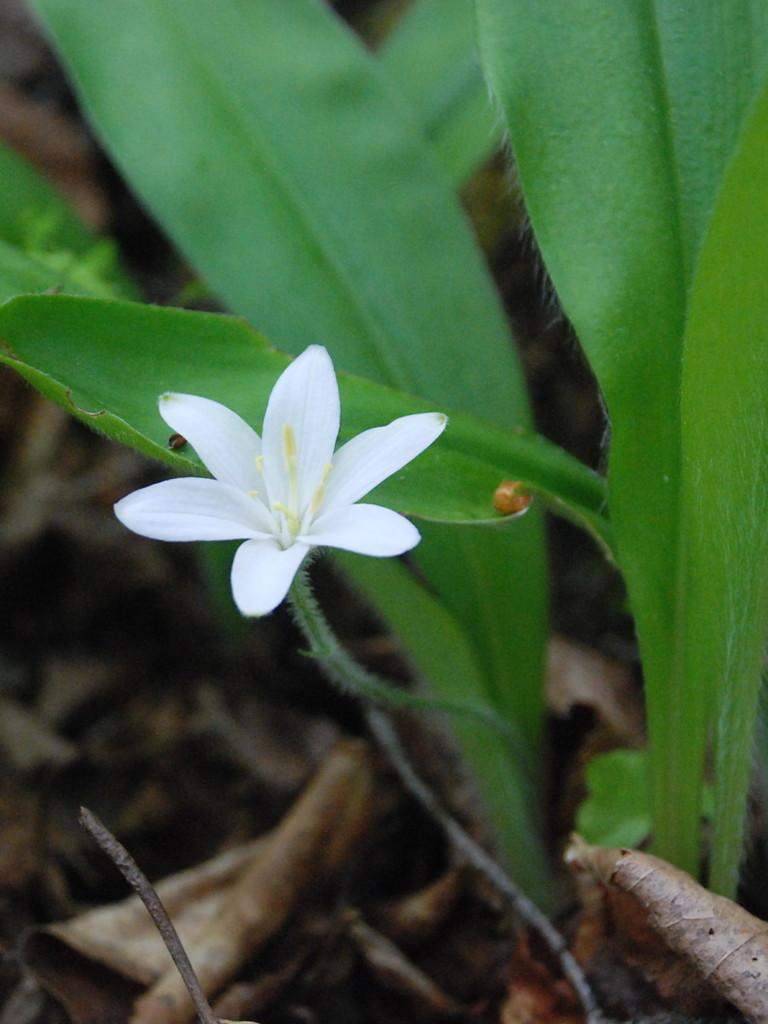What is the main subject of the image? There is a white color flower in the center of the image. What can be seen in the background of the image? There are leaves in the background area of the image. What is the flower writing on the leaves in the image? The flower is not writing on the leaves in the image, as flowers do not have the ability to write. 